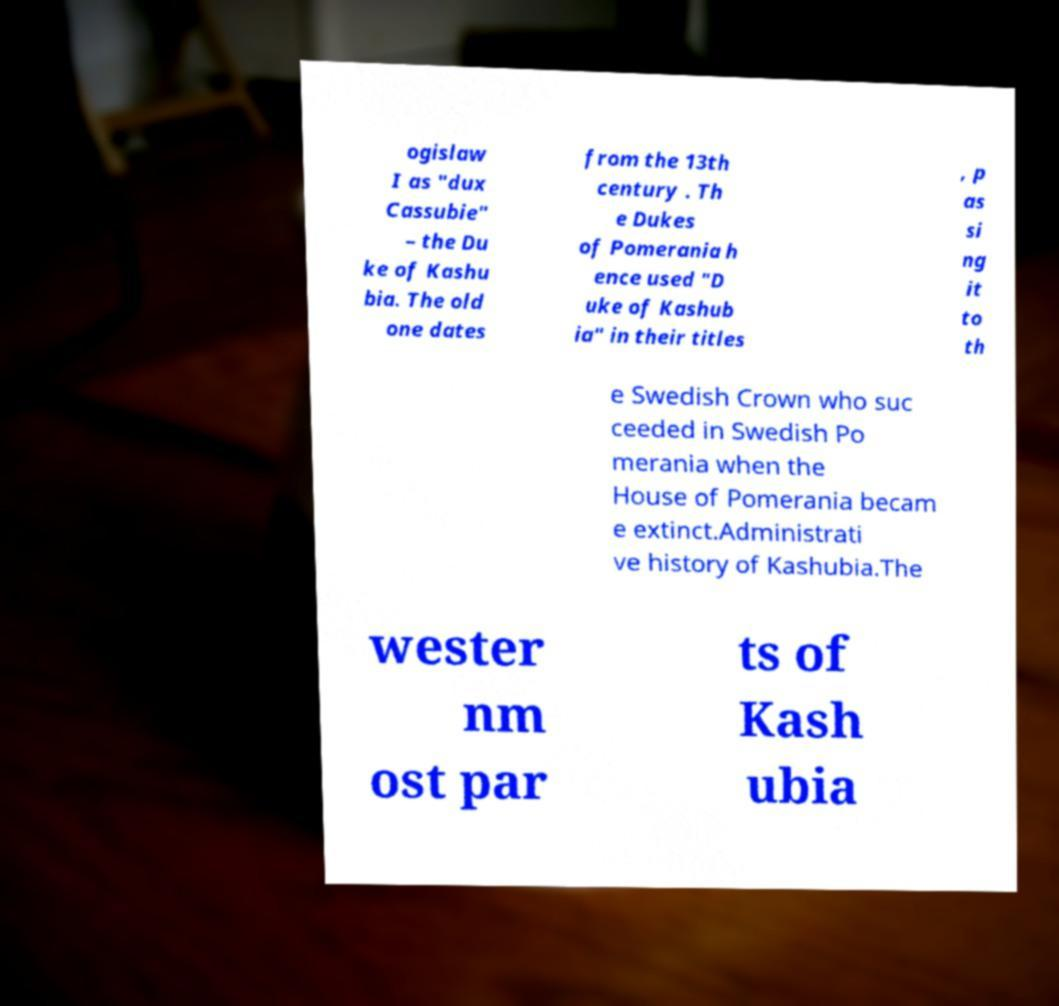Can you read and provide the text displayed in the image?This photo seems to have some interesting text. Can you extract and type it out for me? ogislaw I as "dux Cassubie" – the Du ke of Kashu bia. The old one dates from the 13th century . Th e Dukes of Pomerania h ence used "D uke of Kashub ia" in their titles , p as si ng it to th e Swedish Crown who suc ceeded in Swedish Po merania when the House of Pomerania becam e extinct.Administrati ve history of Kashubia.The wester nm ost par ts of Kash ubia 